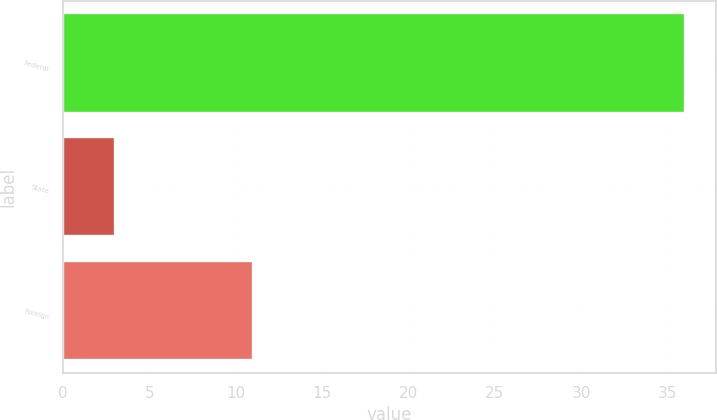Convert chart. <chart><loc_0><loc_0><loc_500><loc_500><bar_chart><fcel>Federal<fcel>State<fcel>Foreign<nl><fcel>36<fcel>3<fcel>11<nl></chart> 